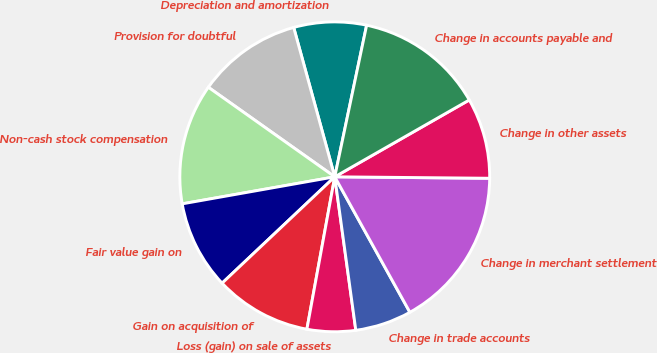Convert chart to OTSL. <chart><loc_0><loc_0><loc_500><loc_500><pie_chart><fcel>Depreciation and amortization<fcel>Provision for doubtful<fcel>Non-cash stock compensation<fcel>Fair value gain on<fcel>Gain on acquisition of<fcel>Loss (gain) on sale of assets<fcel>Change in trade accounts<fcel>Change in merchant settlement<fcel>Change in other assets<fcel>Change in accounts payable and<nl><fcel>7.57%<fcel>10.92%<fcel>12.6%<fcel>9.25%<fcel>10.08%<fcel>5.05%<fcel>5.89%<fcel>16.79%<fcel>8.41%<fcel>13.44%<nl></chart> 